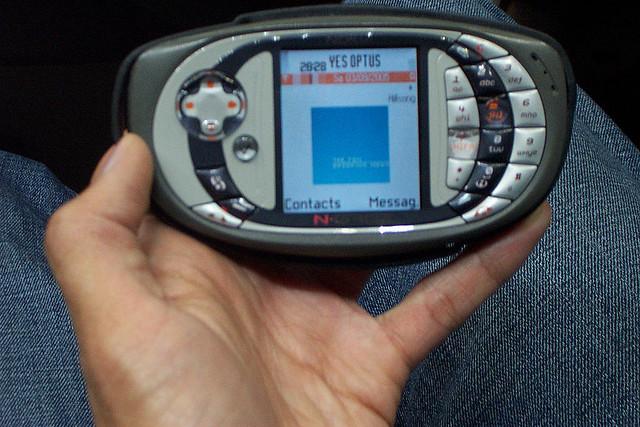What color is the thing in the man's hand?
Be succinct. Gray. Can you send a message on this?
Give a very brief answer. Yes. Is this person holding the device in their left of right hand?
Write a very short answer. Left. What kind of device is this?
Answer briefly. Phone. 